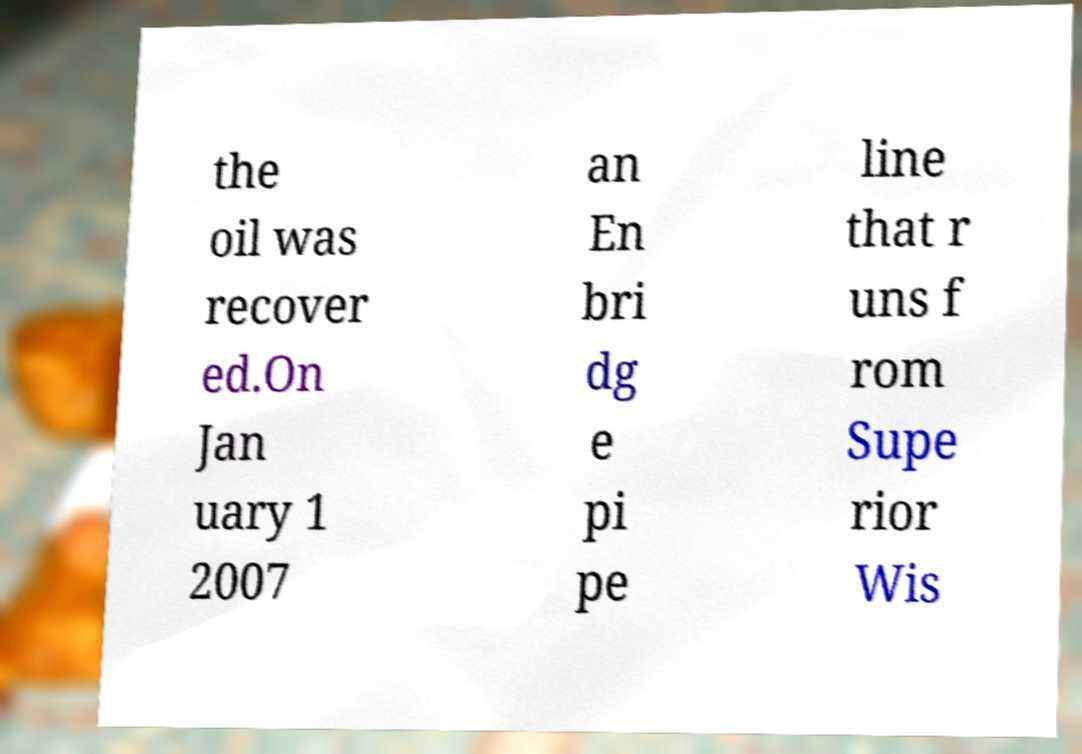For documentation purposes, I need the text within this image transcribed. Could you provide that? the oil was recover ed.On Jan uary 1 2007 an En bri dg e pi pe line that r uns f rom Supe rior Wis 